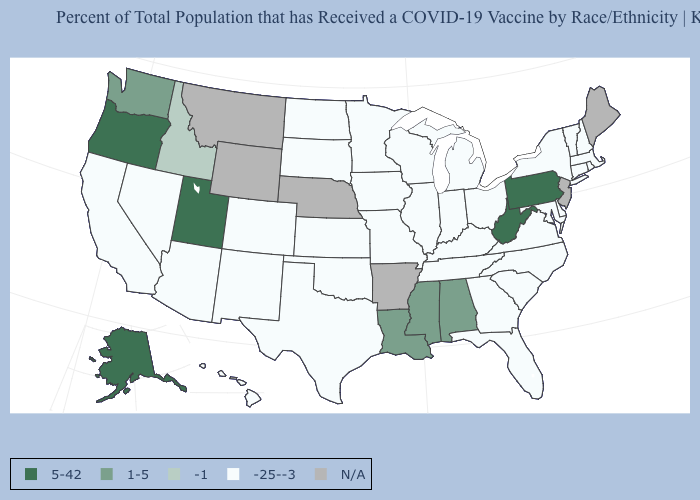Does the map have missing data?
Short answer required. Yes. Name the states that have a value in the range -25--3?
Keep it brief. Arizona, California, Colorado, Connecticut, Delaware, Florida, Georgia, Hawaii, Illinois, Indiana, Iowa, Kansas, Kentucky, Maryland, Massachusetts, Michigan, Minnesota, Missouri, Nevada, New Hampshire, New Mexico, New York, North Carolina, North Dakota, Ohio, Oklahoma, Rhode Island, South Carolina, South Dakota, Tennessee, Texas, Vermont, Virginia, Wisconsin. How many symbols are there in the legend?
Short answer required. 5. Among the states that border Georgia , which have the lowest value?
Quick response, please. Florida, North Carolina, South Carolina, Tennessee. What is the value of Indiana?
Short answer required. -25--3. Among the states that border Washington , which have the lowest value?
Quick response, please. Idaho. Does the first symbol in the legend represent the smallest category?
Quick response, please. No. Among the states that border Iowa , which have the highest value?
Write a very short answer. Illinois, Minnesota, Missouri, South Dakota, Wisconsin. What is the highest value in states that border New Jersey?
Concise answer only. 5-42. What is the lowest value in the South?
Keep it brief. -25--3. Name the states that have a value in the range 5-42?
Quick response, please. Alaska, Oregon, Pennsylvania, Utah, West Virginia. Is the legend a continuous bar?
Quick response, please. No. Name the states that have a value in the range -25--3?
Keep it brief. Arizona, California, Colorado, Connecticut, Delaware, Florida, Georgia, Hawaii, Illinois, Indiana, Iowa, Kansas, Kentucky, Maryland, Massachusetts, Michigan, Minnesota, Missouri, Nevada, New Hampshire, New Mexico, New York, North Carolina, North Dakota, Ohio, Oklahoma, Rhode Island, South Carolina, South Dakota, Tennessee, Texas, Vermont, Virginia, Wisconsin. Name the states that have a value in the range N/A?
Answer briefly. Arkansas, Maine, Montana, Nebraska, New Jersey, Wyoming. Among the states that border Mississippi , does Alabama have the lowest value?
Write a very short answer. No. 